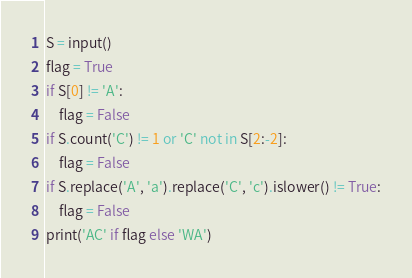<code> <loc_0><loc_0><loc_500><loc_500><_Python_>S = input()
flag = True
if S[0] != 'A':
    flag = False
if S.count('C') != 1 or 'C' not in S[2:-2]:
    flag = False
if S.replace('A', 'a').replace('C', 'c').islower() != True:
    flag = False
print('AC' if flag else 'WA')
</code> 